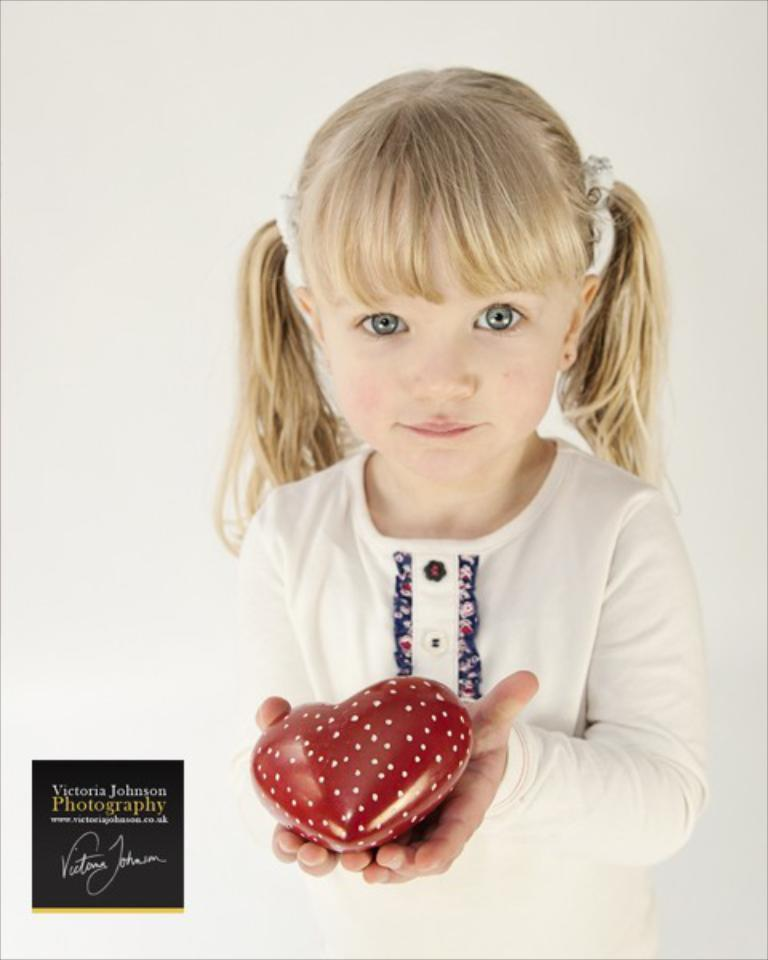Who is the main subject in the image? There is a girl in the image. What is the girl doing in the image? The girl is standing. What is the girl holding in the image? The girl is holding a red color object. What is the color of the background in the image? The background of the image is white. Is there a hose visible in the image? No, there is no hose present in the image. What type of party is being held in the image? There is no party depicted in the image; it only features a girl standing and holding a red object. 